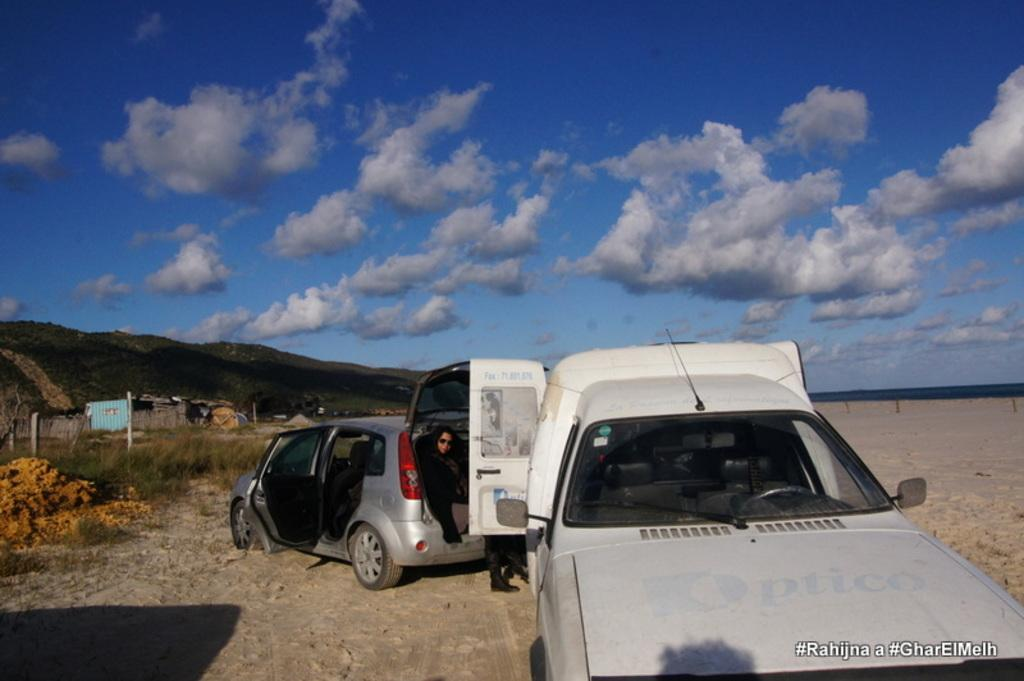What is the person in the image doing? There is a person sitting in a car in the image. How many vehicles are present in the image? There are two vehicles in the image. What type of landscape can be seen in the image? There are many hills in the image. What is the condition of the sky in the image? The sky is clouded and blue in the image. What type of brass instrument is the person playing in the image? There is no brass instrument present in the image; the person is sitting in a car. 